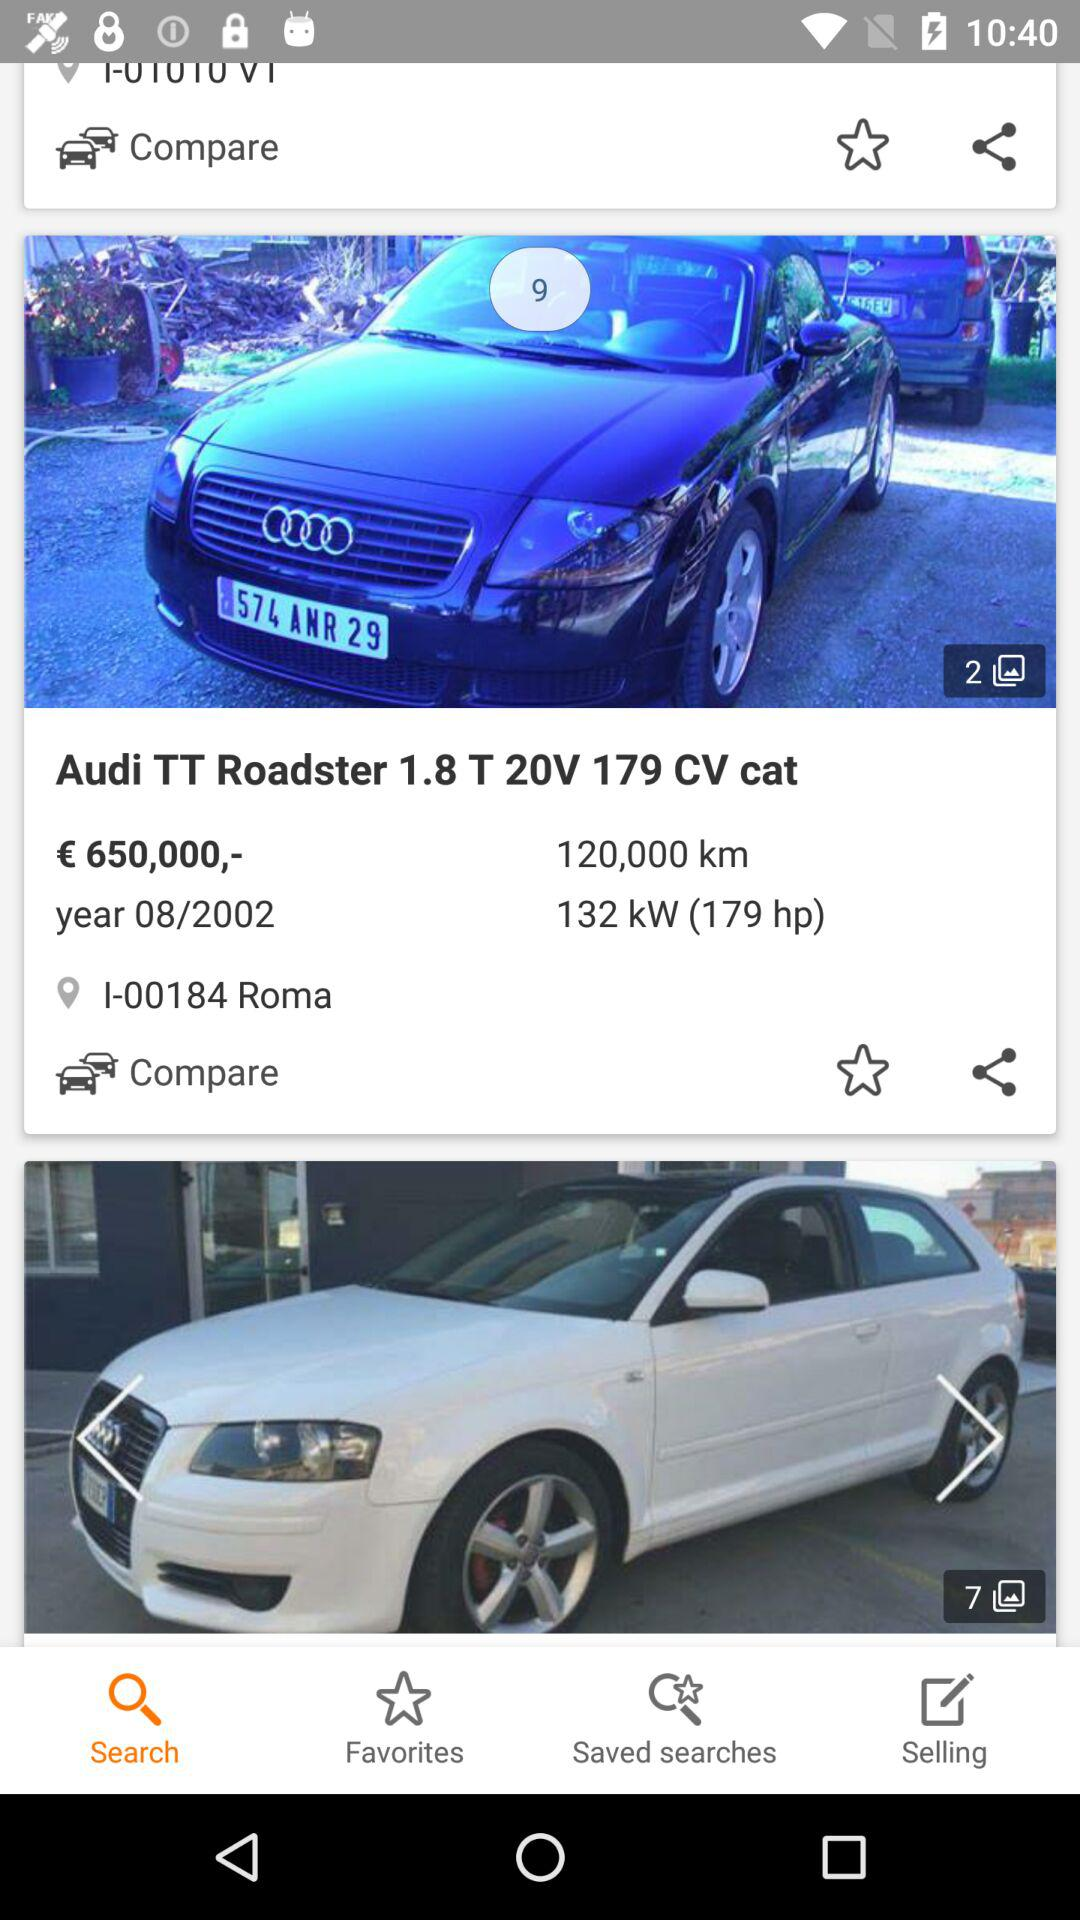How many kilometers are given for the "Audi TT Roadster"? The given kilometers for the "Audi TT Roadster" are 120,000. 